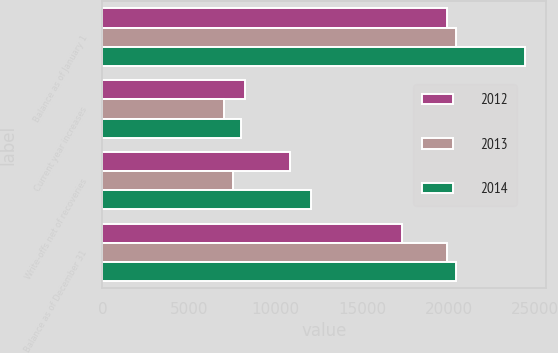Convert chart. <chart><loc_0><loc_0><loc_500><loc_500><stacked_bar_chart><ecel><fcel>Balance as of January 1<fcel>Current year increases<fcel>Write-offs net of recoveries<fcel>Balance as of December 31<nl><fcel>2012<fcel>19895<fcel>8243<fcel>10832<fcel>17306<nl><fcel>2013<fcel>20406<fcel>7025<fcel>7536<fcel>19895<nl><fcel>2014<fcel>24412<fcel>8028<fcel>12034<fcel>20406<nl></chart> 